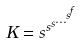<formula> <loc_0><loc_0><loc_500><loc_500>K = s ^ { s ^ { s ^ { \dots ^ { s ^ { f } } } } }</formula> 